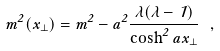Convert formula to latex. <formula><loc_0><loc_0><loc_500><loc_500>m ^ { 2 } ( x _ { \perp } ) = m ^ { 2 } - a ^ { 2 } \frac { \lambda ( \lambda - 1 ) } { \cosh ^ { 2 } a x _ { \perp } } \ ,</formula> 